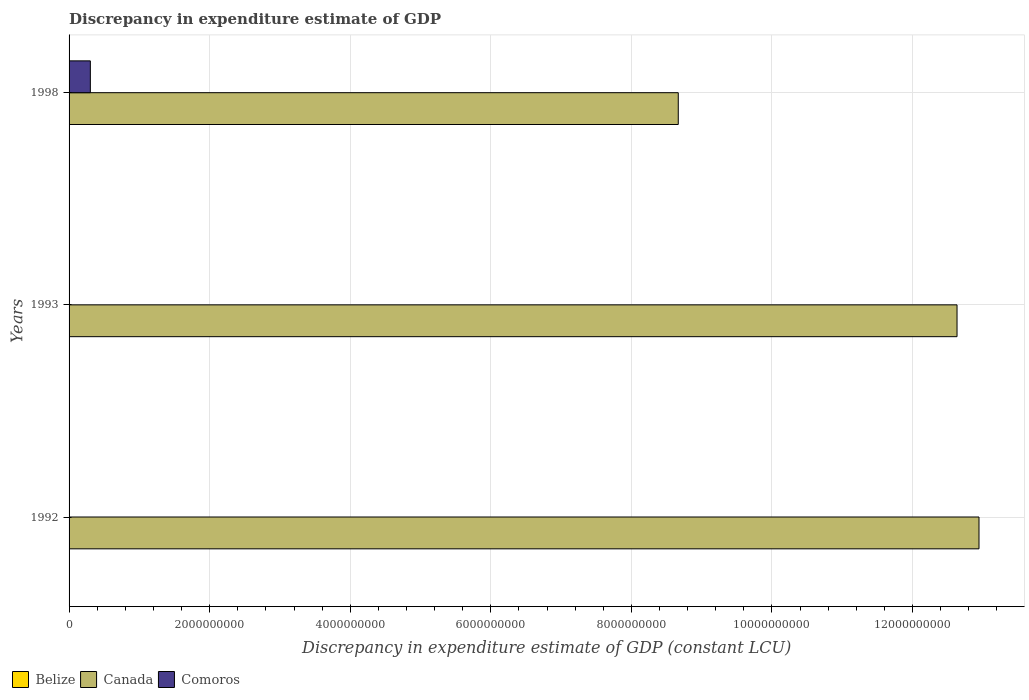How many different coloured bars are there?
Provide a short and direct response. 2. How many bars are there on the 2nd tick from the bottom?
Provide a succinct answer. 1. Across all years, what is the maximum discrepancy in expenditure estimate of GDP in Canada?
Your answer should be compact. 1.29e+1. In which year was the discrepancy in expenditure estimate of GDP in Comoros maximum?
Give a very brief answer. 1998. What is the total discrepancy in expenditure estimate of GDP in Canada in the graph?
Your response must be concise. 3.42e+1. What is the difference between the discrepancy in expenditure estimate of GDP in Canada in 1992 and that in 1993?
Make the answer very short. 3.12e+08. What is the difference between the discrepancy in expenditure estimate of GDP in Belize in 1992 and the discrepancy in expenditure estimate of GDP in Canada in 1998?
Offer a terse response. -8.67e+09. What is the average discrepancy in expenditure estimate of GDP in Comoros per year?
Give a very brief answer. 1.01e+08. In the year 1998, what is the difference between the discrepancy in expenditure estimate of GDP in Canada and discrepancy in expenditure estimate of GDP in Comoros?
Provide a short and direct response. 8.36e+09. In how many years, is the discrepancy in expenditure estimate of GDP in Canada greater than 5200000000 LCU?
Provide a succinct answer. 3. What is the ratio of the discrepancy in expenditure estimate of GDP in Canada in 1993 to that in 1998?
Give a very brief answer. 1.46. What is the difference between the highest and the second highest discrepancy in expenditure estimate of GDP in Canada?
Your answer should be compact. 3.12e+08. What is the difference between the highest and the lowest discrepancy in expenditure estimate of GDP in Canada?
Provide a succinct answer. 4.28e+09. Is the sum of the discrepancy in expenditure estimate of GDP in Canada in 1992 and 1993 greater than the maximum discrepancy in expenditure estimate of GDP in Comoros across all years?
Make the answer very short. Yes. Is it the case that in every year, the sum of the discrepancy in expenditure estimate of GDP in Belize and discrepancy in expenditure estimate of GDP in Canada is greater than the discrepancy in expenditure estimate of GDP in Comoros?
Ensure brevity in your answer.  Yes. How many years are there in the graph?
Provide a succinct answer. 3. What is the difference between two consecutive major ticks on the X-axis?
Offer a terse response. 2.00e+09. Does the graph contain grids?
Provide a short and direct response. Yes. How are the legend labels stacked?
Your response must be concise. Horizontal. What is the title of the graph?
Provide a succinct answer. Discrepancy in expenditure estimate of GDP. What is the label or title of the X-axis?
Provide a succinct answer. Discrepancy in expenditure estimate of GDP (constant LCU). What is the Discrepancy in expenditure estimate of GDP (constant LCU) of Canada in 1992?
Your answer should be compact. 1.29e+1. What is the Discrepancy in expenditure estimate of GDP (constant LCU) in Canada in 1993?
Your answer should be compact. 1.26e+1. What is the Discrepancy in expenditure estimate of GDP (constant LCU) of Canada in 1998?
Provide a succinct answer. 8.67e+09. What is the Discrepancy in expenditure estimate of GDP (constant LCU) in Comoros in 1998?
Make the answer very short. 3.03e+08. Across all years, what is the maximum Discrepancy in expenditure estimate of GDP (constant LCU) in Canada?
Your response must be concise. 1.29e+1. Across all years, what is the maximum Discrepancy in expenditure estimate of GDP (constant LCU) in Comoros?
Your answer should be compact. 3.03e+08. Across all years, what is the minimum Discrepancy in expenditure estimate of GDP (constant LCU) of Canada?
Your answer should be compact. 8.67e+09. Across all years, what is the minimum Discrepancy in expenditure estimate of GDP (constant LCU) in Comoros?
Make the answer very short. 0. What is the total Discrepancy in expenditure estimate of GDP (constant LCU) of Canada in the graph?
Offer a terse response. 3.42e+1. What is the total Discrepancy in expenditure estimate of GDP (constant LCU) in Comoros in the graph?
Your response must be concise. 3.03e+08. What is the difference between the Discrepancy in expenditure estimate of GDP (constant LCU) in Canada in 1992 and that in 1993?
Offer a very short reply. 3.12e+08. What is the difference between the Discrepancy in expenditure estimate of GDP (constant LCU) in Canada in 1992 and that in 1998?
Your answer should be very brief. 4.28e+09. What is the difference between the Discrepancy in expenditure estimate of GDP (constant LCU) in Canada in 1993 and that in 1998?
Your answer should be very brief. 3.97e+09. What is the difference between the Discrepancy in expenditure estimate of GDP (constant LCU) in Canada in 1992 and the Discrepancy in expenditure estimate of GDP (constant LCU) in Comoros in 1998?
Your answer should be compact. 1.26e+1. What is the difference between the Discrepancy in expenditure estimate of GDP (constant LCU) of Canada in 1993 and the Discrepancy in expenditure estimate of GDP (constant LCU) of Comoros in 1998?
Your response must be concise. 1.23e+1. What is the average Discrepancy in expenditure estimate of GDP (constant LCU) in Belize per year?
Your answer should be compact. 0. What is the average Discrepancy in expenditure estimate of GDP (constant LCU) in Canada per year?
Provide a short and direct response. 1.14e+1. What is the average Discrepancy in expenditure estimate of GDP (constant LCU) in Comoros per year?
Offer a very short reply. 1.01e+08. In the year 1998, what is the difference between the Discrepancy in expenditure estimate of GDP (constant LCU) of Canada and Discrepancy in expenditure estimate of GDP (constant LCU) of Comoros?
Your answer should be very brief. 8.36e+09. What is the ratio of the Discrepancy in expenditure estimate of GDP (constant LCU) of Canada in 1992 to that in 1993?
Give a very brief answer. 1.02. What is the ratio of the Discrepancy in expenditure estimate of GDP (constant LCU) of Canada in 1992 to that in 1998?
Offer a very short reply. 1.49. What is the ratio of the Discrepancy in expenditure estimate of GDP (constant LCU) in Canada in 1993 to that in 1998?
Keep it short and to the point. 1.46. What is the difference between the highest and the second highest Discrepancy in expenditure estimate of GDP (constant LCU) in Canada?
Give a very brief answer. 3.12e+08. What is the difference between the highest and the lowest Discrepancy in expenditure estimate of GDP (constant LCU) of Canada?
Make the answer very short. 4.28e+09. What is the difference between the highest and the lowest Discrepancy in expenditure estimate of GDP (constant LCU) of Comoros?
Keep it short and to the point. 3.03e+08. 